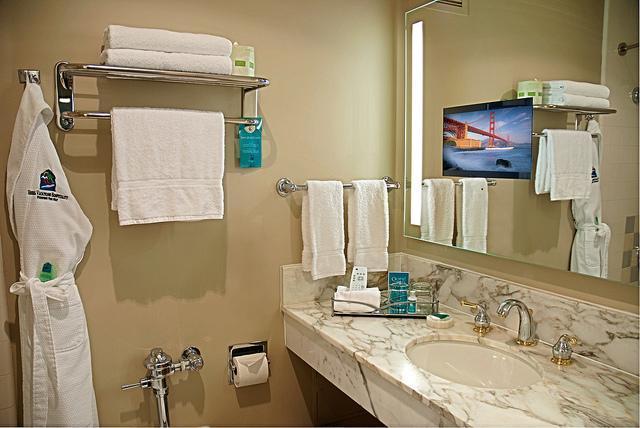How many towels are hanging not folded?
Give a very brief answer. 3. How many tvs are there?
Give a very brief answer. 1. 